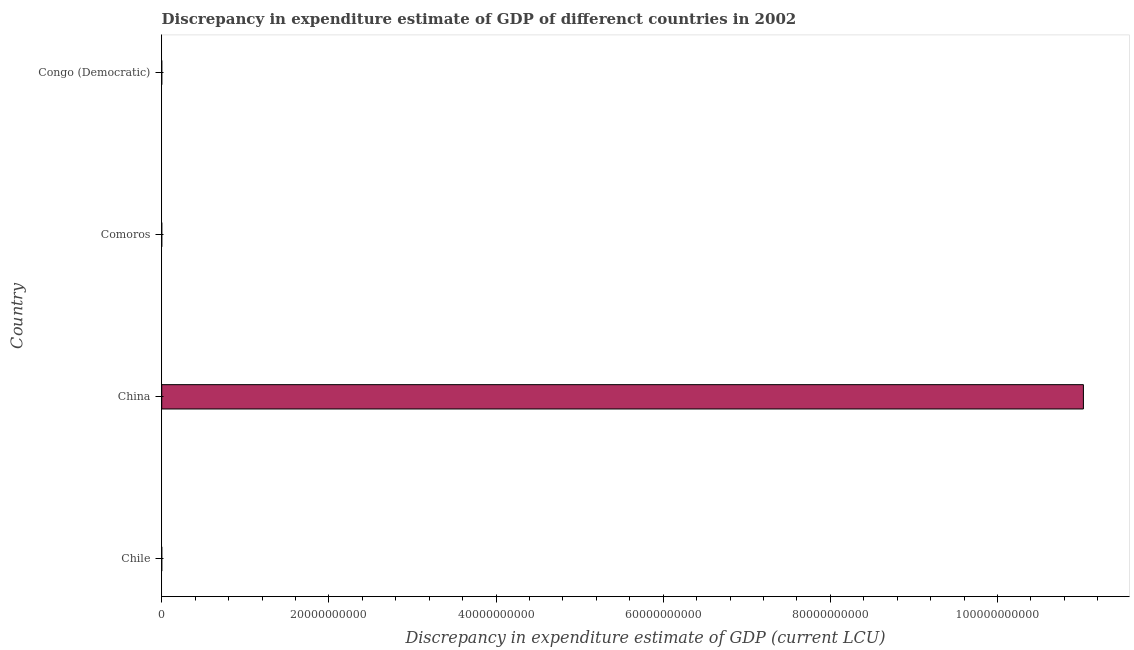Does the graph contain grids?
Your answer should be compact. No. What is the title of the graph?
Your response must be concise. Discrepancy in expenditure estimate of GDP of differenct countries in 2002. What is the label or title of the X-axis?
Give a very brief answer. Discrepancy in expenditure estimate of GDP (current LCU). What is the label or title of the Y-axis?
Provide a short and direct response. Country. What is the discrepancy in expenditure estimate of gdp in China?
Your response must be concise. 1.10e+11. Across all countries, what is the maximum discrepancy in expenditure estimate of gdp?
Provide a short and direct response. 1.10e+11. Across all countries, what is the minimum discrepancy in expenditure estimate of gdp?
Your answer should be compact. 4e-6. In which country was the discrepancy in expenditure estimate of gdp maximum?
Your answer should be compact. China. In which country was the discrepancy in expenditure estimate of gdp minimum?
Your response must be concise. Comoros. What is the sum of the discrepancy in expenditure estimate of gdp?
Offer a terse response. 1.10e+11. What is the difference between the discrepancy in expenditure estimate of gdp in China and Comoros?
Offer a terse response. 1.10e+11. What is the average discrepancy in expenditure estimate of gdp per country?
Make the answer very short. 2.76e+1. What is the median discrepancy in expenditure estimate of gdp?
Offer a very short reply. 50. In how many countries, is the discrepancy in expenditure estimate of gdp greater than 96000000000 LCU?
Your response must be concise. 1. What is the ratio of the discrepancy in expenditure estimate of gdp in Comoros to that in Congo (Democratic)?
Your answer should be very brief. 0.01. What is the difference between the highest and the second highest discrepancy in expenditure estimate of gdp?
Offer a very short reply. 1.10e+11. What is the difference between the highest and the lowest discrepancy in expenditure estimate of gdp?
Ensure brevity in your answer.  1.10e+11. How many bars are there?
Your answer should be compact. 4. Are all the bars in the graph horizontal?
Make the answer very short. Yes. What is the Discrepancy in expenditure estimate of GDP (current LCU) of China?
Make the answer very short. 1.10e+11. What is the Discrepancy in expenditure estimate of GDP (current LCU) in Comoros?
Give a very brief answer. 4e-6. What is the Discrepancy in expenditure estimate of GDP (current LCU) in Congo (Democratic)?
Offer a terse response. 0. What is the difference between the Discrepancy in expenditure estimate of GDP (current LCU) in Chile and China?
Your answer should be very brief. -1.10e+11. What is the difference between the Discrepancy in expenditure estimate of GDP (current LCU) in Chile and Congo (Democratic)?
Offer a very short reply. 100. What is the difference between the Discrepancy in expenditure estimate of GDP (current LCU) in China and Comoros?
Ensure brevity in your answer.  1.10e+11. What is the difference between the Discrepancy in expenditure estimate of GDP (current LCU) in China and Congo (Democratic)?
Make the answer very short. 1.10e+11. What is the difference between the Discrepancy in expenditure estimate of GDP (current LCU) in Comoros and Congo (Democratic)?
Your response must be concise. -0. What is the ratio of the Discrepancy in expenditure estimate of GDP (current LCU) in Chile to that in China?
Your answer should be compact. 0. What is the ratio of the Discrepancy in expenditure estimate of GDP (current LCU) in Chile to that in Comoros?
Offer a very short reply. 2.50e+07. What is the ratio of the Discrepancy in expenditure estimate of GDP (current LCU) in China to that in Comoros?
Keep it short and to the point. 2.757212475e+16. What is the ratio of the Discrepancy in expenditure estimate of GDP (current LCU) in China to that in Congo (Democratic)?
Offer a very short reply. 2.21e+14. What is the ratio of the Discrepancy in expenditure estimate of GDP (current LCU) in Comoros to that in Congo (Democratic)?
Offer a terse response. 0.01. 